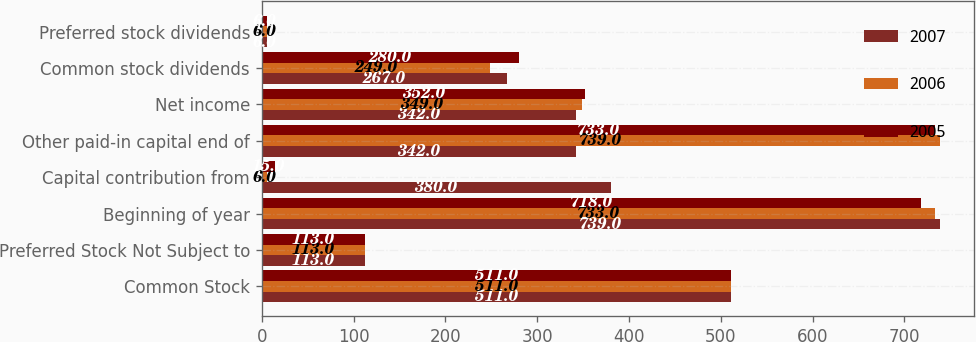Convert chart to OTSL. <chart><loc_0><loc_0><loc_500><loc_500><stacked_bar_chart><ecel><fcel>Common Stock<fcel>Preferred Stock Not Subject to<fcel>Beginning of year<fcel>Capital contribution from<fcel>Other paid-in capital end of<fcel>Net income<fcel>Common stock dividends<fcel>Preferred stock dividends<nl><fcel>2007<fcel>511<fcel>113<fcel>739<fcel>380<fcel>342<fcel>342<fcel>267<fcel>6<nl><fcel>2006<fcel>511<fcel>113<fcel>733<fcel>6<fcel>739<fcel>349<fcel>249<fcel>6<nl><fcel>2005<fcel>511<fcel>113<fcel>718<fcel>15<fcel>733<fcel>352<fcel>280<fcel>6<nl></chart> 